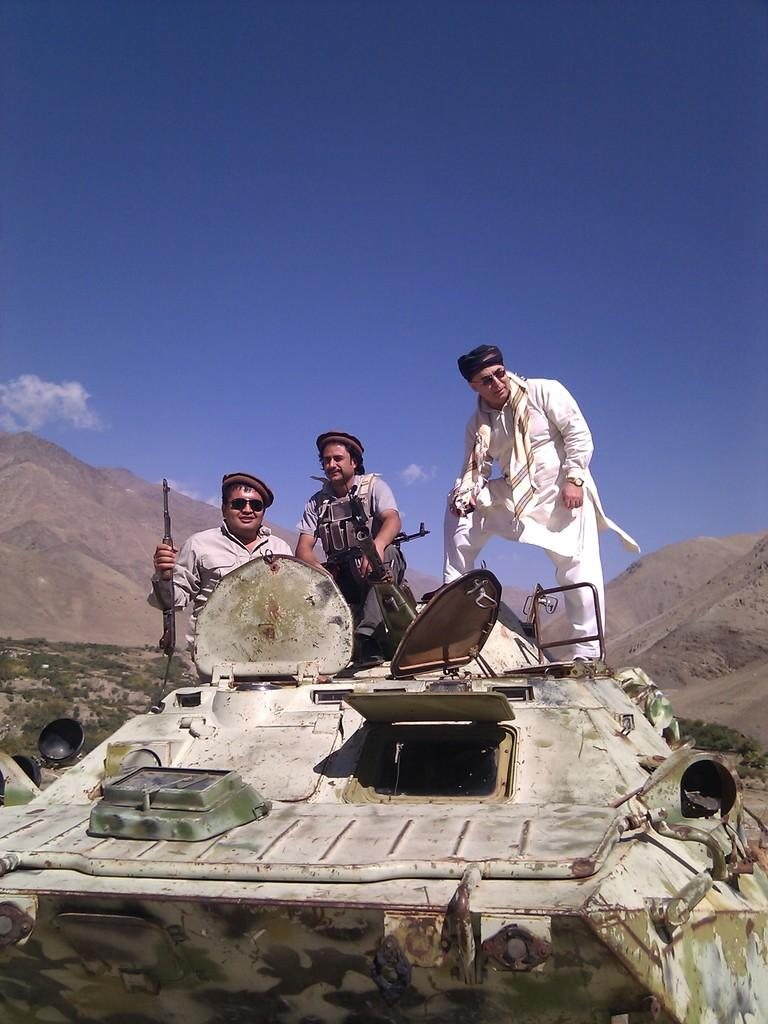What is the main subject of the image? There is a battle machine in the image. Who or what is on the battle machine? Three men are standing on the battle machine. What can be seen on the left side of the image? There are hills on the left side of the image. What is visible at the top of the image? The sky is visible at the top of the image. What type of dress is the battle machine wearing in the image? The battle machine is not a person and therefore cannot wear a dress. --- Facts: 1. There is a person holding a book in the image. 2. The person is sitting on a chair. 3. There is a table next to the chair. 4. The background of the image is a room. Absurd Topics: fish, ocean, waves Conversation: What is the person in the image doing? The person is holding a book in the image. Where is the person sitting? The person is sitting on a chair. What is located next to the chair? There is a table next to the chair. What type of setting is visible in the background of the image? The background of the image is a room. Reasoning: Let's think step by step in order to produce the conversation. We start by identifying the main subject of the image, which is the person holding a book. Then, we describe the person's position and the objects around them, such as the chair and table. Finally, we mention the setting visible in the background, which is a room. Absurd Question/Answer: Can you see any fish or ocean waves in the image? No, there are no fish or ocean waves present in the image; the background is a room. 